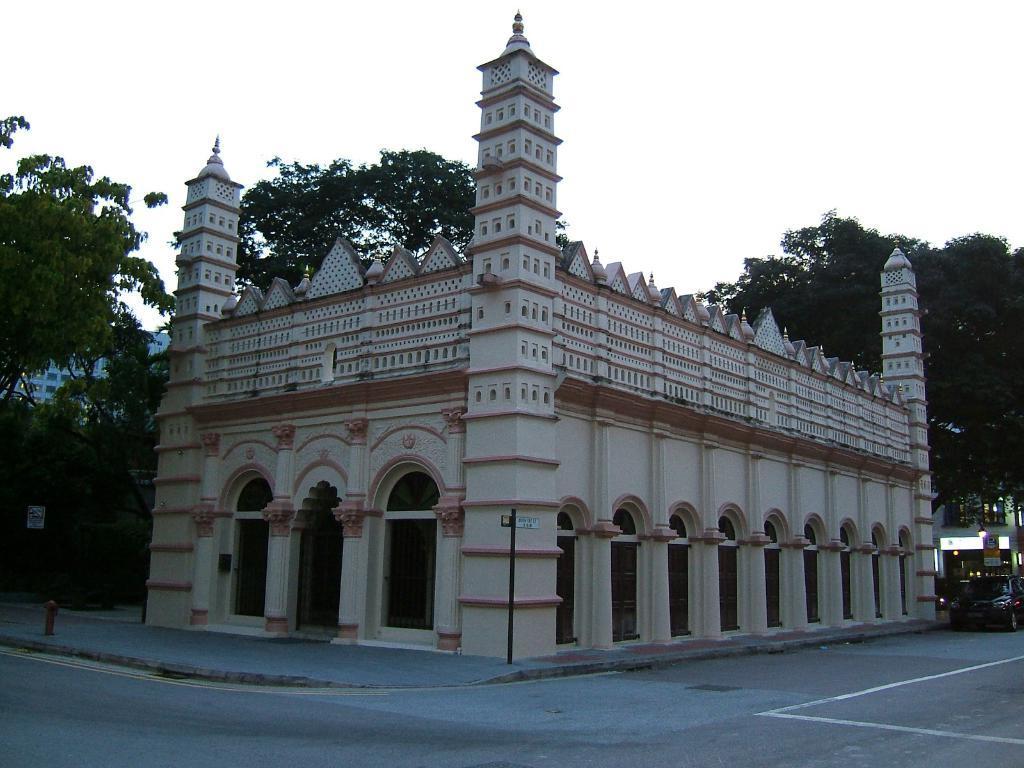Describe this image in one or two sentences. In this image we can see buildings, hydrant, trees, motor vehicle on the road, sign boards and sky. 